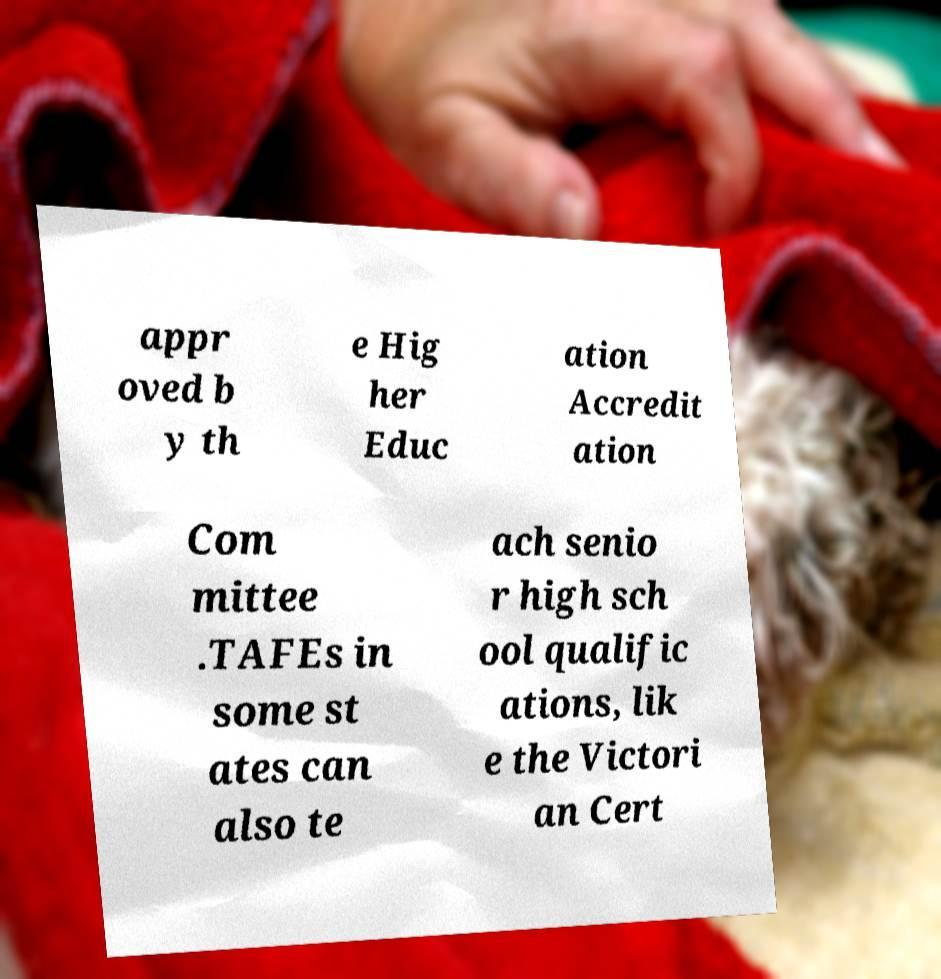For documentation purposes, I need the text within this image transcribed. Could you provide that? appr oved b y th e Hig her Educ ation Accredit ation Com mittee .TAFEs in some st ates can also te ach senio r high sch ool qualific ations, lik e the Victori an Cert 